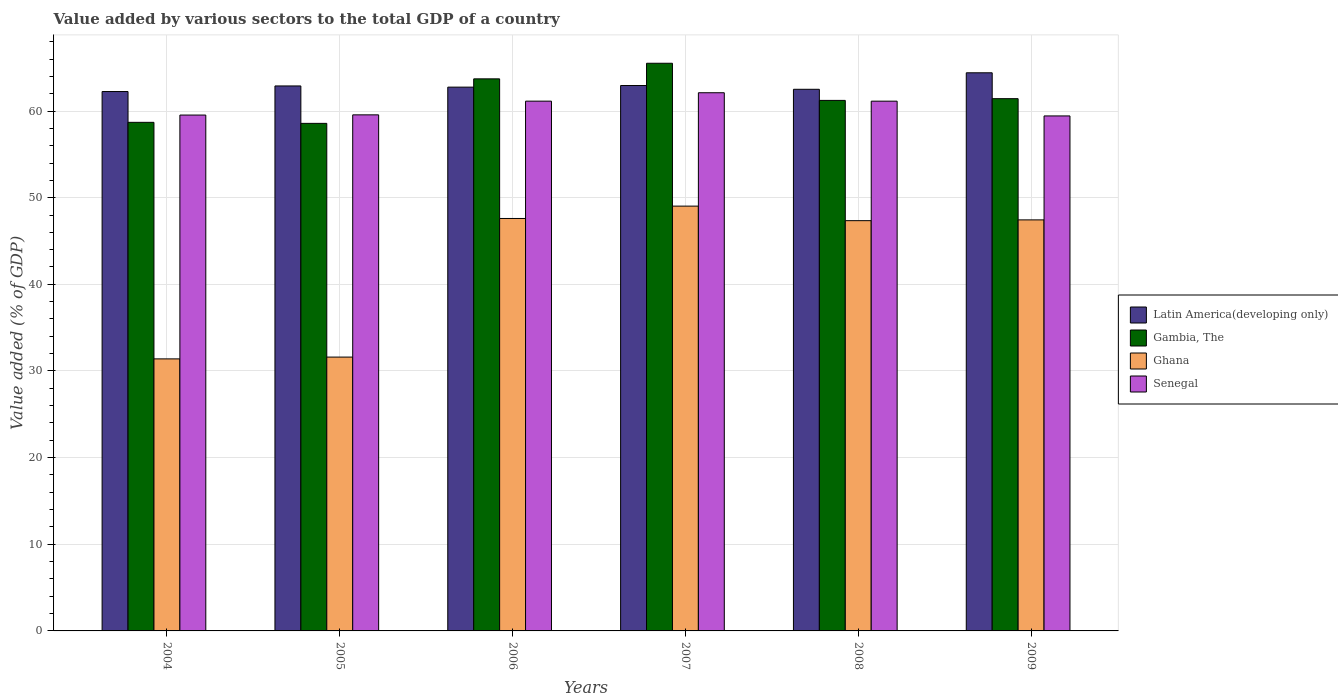How many different coloured bars are there?
Ensure brevity in your answer.  4. Are the number of bars per tick equal to the number of legend labels?
Provide a succinct answer. Yes. How many bars are there on the 6th tick from the right?
Your answer should be compact. 4. What is the label of the 3rd group of bars from the left?
Offer a very short reply. 2006. In how many cases, is the number of bars for a given year not equal to the number of legend labels?
Your answer should be compact. 0. What is the value added by various sectors to the total GDP in Latin America(developing only) in 2009?
Ensure brevity in your answer.  64.41. Across all years, what is the maximum value added by various sectors to the total GDP in Ghana?
Ensure brevity in your answer.  49.03. Across all years, what is the minimum value added by various sectors to the total GDP in Gambia, The?
Your answer should be compact. 58.58. What is the total value added by various sectors to the total GDP in Gambia, The in the graph?
Your answer should be very brief. 369.15. What is the difference between the value added by various sectors to the total GDP in Ghana in 2008 and that in 2009?
Ensure brevity in your answer.  -0.09. What is the difference between the value added by various sectors to the total GDP in Gambia, The in 2009 and the value added by various sectors to the total GDP in Ghana in 2006?
Your response must be concise. 13.83. What is the average value added by various sectors to the total GDP in Gambia, The per year?
Ensure brevity in your answer.  61.53. In the year 2007, what is the difference between the value added by various sectors to the total GDP in Gambia, The and value added by various sectors to the total GDP in Senegal?
Offer a terse response. 3.4. What is the ratio of the value added by various sectors to the total GDP in Senegal in 2005 to that in 2007?
Keep it short and to the point. 0.96. What is the difference between the highest and the second highest value added by various sectors to the total GDP in Gambia, The?
Offer a very short reply. 1.8. What is the difference between the highest and the lowest value added by various sectors to the total GDP in Gambia, The?
Provide a succinct answer. 6.94. In how many years, is the value added by various sectors to the total GDP in Gambia, The greater than the average value added by various sectors to the total GDP in Gambia, The taken over all years?
Your answer should be very brief. 2. Is it the case that in every year, the sum of the value added by various sectors to the total GDP in Latin America(developing only) and value added by various sectors to the total GDP in Ghana is greater than the sum of value added by various sectors to the total GDP in Gambia, The and value added by various sectors to the total GDP in Senegal?
Ensure brevity in your answer.  No. What does the 2nd bar from the left in 2005 represents?
Offer a very short reply. Gambia, The. What does the 1st bar from the right in 2008 represents?
Provide a succinct answer. Senegal. How many years are there in the graph?
Ensure brevity in your answer.  6. Are the values on the major ticks of Y-axis written in scientific E-notation?
Give a very brief answer. No. How are the legend labels stacked?
Offer a terse response. Vertical. What is the title of the graph?
Offer a terse response. Value added by various sectors to the total GDP of a country. Does "Tonga" appear as one of the legend labels in the graph?
Offer a very short reply. No. What is the label or title of the Y-axis?
Provide a succinct answer. Value added (% of GDP). What is the Value added (% of GDP) of Latin America(developing only) in 2004?
Make the answer very short. 62.25. What is the Value added (% of GDP) of Gambia, The in 2004?
Your response must be concise. 58.7. What is the Value added (% of GDP) in Ghana in 2004?
Make the answer very short. 31.39. What is the Value added (% of GDP) in Senegal in 2004?
Your answer should be very brief. 59.54. What is the Value added (% of GDP) of Latin America(developing only) in 2005?
Provide a short and direct response. 62.89. What is the Value added (% of GDP) of Gambia, The in 2005?
Provide a short and direct response. 58.58. What is the Value added (% of GDP) of Ghana in 2005?
Offer a very short reply. 31.6. What is the Value added (% of GDP) in Senegal in 2005?
Keep it short and to the point. 59.56. What is the Value added (% of GDP) in Latin America(developing only) in 2006?
Your response must be concise. 62.76. What is the Value added (% of GDP) of Gambia, The in 2006?
Make the answer very short. 63.71. What is the Value added (% of GDP) of Ghana in 2006?
Your answer should be compact. 47.6. What is the Value added (% of GDP) in Senegal in 2006?
Give a very brief answer. 61.14. What is the Value added (% of GDP) of Latin America(developing only) in 2007?
Provide a short and direct response. 62.94. What is the Value added (% of GDP) of Gambia, The in 2007?
Offer a very short reply. 65.51. What is the Value added (% of GDP) in Ghana in 2007?
Your response must be concise. 49.03. What is the Value added (% of GDP) of Senegal in 2007?
Provide a succinct answer. 62.11. What is the Value added (% of GDP) in Latin America(developing only) in 2008?
Ensure brevity in your answer.  62.51. What is the Value added (% of GDP) of Gambia, The in 2008?
Offer a very short reply. 61.23. What is the Value added (% of GDP) in Ghana in 2008?
Make the answer very short. 47.35. What is the Value added (% of GDP) in Senegal in 2008?
Your response must be concise. 61.14. What is the Value added (% of GDP) in Latin America(developing only) in 2009?
Keep it short and to the point. 64.41. What is the Value added (% of GDP) of Gambia, The in 2009?
Keep it short and to the point. 61.43. What is the Value added (% of GDP) in Ghana in 2009?
Keep it short and to the point. 47.44. What is the Value added (% of GDP) of Senegal in 2009?
Offer a terse response. 59.43. Across all years, what is the maximum Value added (% of GDP) in Latin America(developing only)?
Provide a succinct answer. 64.41. Across all years, what is the maximum Value added (% of GDP) of Gambia, The?
Your response must be concise. 65.51. Across all years, what is the maximum Value added (% of GDP) in Ghana?
Your answer should be very brief. 49.03. Across all years, what is the maximum Value added (% of GDP) in Senegal?
Make the answer very short. 62.11. Across all years, what is the minimum Value added (% of GDP) of Latin America(developing only)?
Ensure brevity in your answer.  62.25. Across all years, what is the minimum Value added (% of GDP) of Gambia, The?
Make the answer very short. 58.58. Across all years, what is the minimum Value added (% of GDP) in Ghana?
Provide a short and direct response. 31.39. Across all years, what is the minimum Value added (% of GDP) in Senegal?
Make the answer very short. 59.43. What is the total Value added (% of GDP) in Latin America(developing only) in the graph?
Keep it short and to the point. 377.77. What is the total Value added (% of GDP) of Gambia, The in the graph?
Give a very brief answer. 369.15. What is the total Value added (% of GDP) of Ghana in the graph?
Keep it short and to the point. 254.41. What is the total Value added (% of GDP) in Senegal in the graph?
Offer a very short reply. 362.92. What is the difference between the Value added (% of GDP) of Latin America(developing only) in 2004 and that in 2005?
Your answer should be compact. -0.65. What is the difference between the Value added (% of GDP) of Gambia, The in 2004 and that in 2005?
Your response must be concise. 0.12. What is the difference between the Value added (% of GDP) of Ghana in 2004 and that in 2005?
Your answer should be compact. -0.21. What is the difference between the Value added (% of GDP) in Senegal in 2004 and that in 2005?
Your response must be concise. -0.02. What is the difference between the Value added (% of GDP) in Latin America(developing only) in 2004 and that in 2006?
Provide a succinct answer. -0.51. What is the difference between the Value added (% of GDP) in Gambia, The in 2004 and that in 2006?
Provide a short and direct response. -5.02. What is the difference between the Value added (% of GDP) in Ghana in 2004 and that in 2006?
Give a very brief answer. -16.2. What is the difference between the Value added (% of GDP) of Senegal in 2004 and that in 2006?
Make the answer very short. -1.61. What is the difference between the Value added (% of GDP) of Latin America(developing only) in 2004 and that in 2007?
Give a very brief answer. -0.69. What is the difference between the Value added (% of GDP) of Gambia, The in 2004 and that in 2007?
Keep it short and to the point. -6.82. What is the difference between the Value added (% of GDP) in Ghana in 2004 and that in 2007?
Offer a terse response. -17.63. What is the difference between the Value added (% of GDP) in Senegal in 2004 and that in 2007?
Your answer should be compact. -2.57. What is the difference between the Value added (% of GDP) in Latin America(developing only) in 2004 and that in 2008?
Make the answer very short. -0.26. What is the difference between the Value added (% of GDP) of Gambia, The in 2004 and that in 2008?
Make the answer very short. -2.53. What is the difference between the Value added (% of GDP) of Ghana in 2004 and that in 2008?
Provide a short and direct response. -15.95. What is the difference between the Value added (% of GDP) in Senegal in 2004 and that in 2008?
Make the answer very short. -1.6. What is the difference between the Value added (% of GDP) of Latin America(developing only) in 2004 and that in 2009?
Your response must be concise. -2.16. What is the difference between the Value added (% of GDP) in Gambia, The in 2004 and that in 2009?
Keep it short and to the point. -2.73. What is the difference between the Value added (% of GDP) of Ghana in 2004 and that in 2009?
Provide a short and direct response. -16.04. What is the difference between the Value added (% of GDP) in Senegal in 2004 and that in 2009?
Offer a very short reply. 0.1. What is the difference between the Value added (% of GDP) of Latin America(developing only) in 2005 and that in 2006?
Provide a short and direct response. 0.14. What is the difference between the Value added (% of GDP) in Gambia, The in 2005 and that in 2006?
Ensure brevity in your answer.  -5.14. What is the difference between the Value added (% of GDP) in Ghana in 2005 and that in 2006?
Provide a short and direct response. -16. What is the difference between the Value added (% of GDP) of Senegal in 2005 and that in 2006?
Provide a succinct answer. -1.58. What is the difference between the Value added (% of GDP) of Latin America(developing only) in 2005 and that in 2007?
Make the answer very short. -0.05. What is the difference between the Value added (% of GDP) in Gambia, The in 2005 and that in 2007?
Your answer should be compact. -6.94. What is the difference between the Value added (% of GDP) in Ghana in 2005 and that in 2007?
Ensure brevity in your answer.  -17.42. What is the difference between the Value added (% of GDP) of Senegal in 2005 and that in 2007?
Offer a very short reply. -2.55. What is the difference between the Value added (% of GDP) of Latin America(developing only) in 2005 and that in 2008?
Provide a short and direct response. 0.38. What is the difference between the Value added (% of GDP) in Gambia, The in 2005 and that in 2008?
Offer a very short reply. -2.65. What is the difference between the Value added (% of GDP) of Ghana in 2005 and that in 2008?
Make the answer very short. -15.74. What is the difference between the Value added (% of GDP) in Senegal in 2005 and that in 2008?
Your answer should be very brief. -1.58. What is the difference between the Value added (% of GDP) in Latin America(developing only) in 2005 and that in 2009?
Make the answer very short. -1.52. What is the difference between the Value added (% of GDP) of Gambia, The in 2005 and that in 2009?
Provide a short and direct response. -2.85. What is the difference between the Value added (% of GDP) of Ghana in 2005 and that in 2009?
Your answer should be compact. -15.83. What is the difference between the Value added (% of GDP) in Senegal in 2005 and that in 2009?
Ensure brevity in your answer.  0.12. What is the difference between the Value added (% of GDP) of Latin America(developing only) in 2006 and that in 2007?
Ensure brevity in your answer.  -0.19. What is the difference between the Value added (% of GDP) in Gambia, The in 2006 and that in 2007?
Provide a succinct answer. -1.8. What is the difference between the Value added (% of GDP) in Ghana in 2006 and that in 2007?
Keep it short and to the point. -1.43. What is the difference between the Value added (% of GDP) of Senegal in 2006 and that in 2007?
Your answer should be very brief. -0.97. What is the difference between the Value added (% of GDP) of Latin America(developing only) in 2006 and that in 2008?
Make the answer very short. 0.25. What is the difference between the Value added (% of GDP) of Gambia, The in 2006 and that in 2008?
Ensure brevity in your answer.  2.49. What is the difference between the Value added (% of GDP) of Ghana in 2006 and that in 2008?
Your answer should be compact. 0.25. What is the difference between the Value added (% of GDP) in Senegal in 2006 and that in 2008?
Your response must be concise. 0. What is the difference between the Value added (% of GDP) in Latin America(developing only) in 2006 and that in 2009?
Give a very brief answer. -1.66. What is the difference between the Value added (% of GDP) in Gambia, The in 2006 and that in 2009?
Ensure brevity in your answer.  2.29. What is the difference between the Value added (% of GDP) of Ghana in 2006 and that in 2009?
Offer a terse response. 0.16. What is the difference between the Value added (% of GDP) of Senegal in 2006 and that in 2009?
Offer a terse response. 1.71. What is the difference between the Value added (% of GDP) of Latin America(developing only) in 2007 and that in 2008?
Offer a very short reply. 0.43. What is the difference between the Value added (% of GDP) of Gambia, The in 2007 and that in 2008?
Offer a terse response. 4.29. What is the difference between the Value added (% of GDP) in Ghana in 2007 and that in 2008?
Provide a succinct answer. 1.68. What is the difference between the Value added (% of GDP) of Senegal in 2007 and that in 2008?
Your response must be concise. 0.97. What is the difference between the Value added (% of GDP) in Latin America(developing only) in 2007 and that in 2009?
Your answer should be compact. -1.47. What is the difference between the Value added (% of GDP) of Gambia, The in 2007 and that in 2009?
Provide a short and direct response. 4.09. What is the difference between the Value added (% of GDP) in Ghana in 2007 and that in 2009?
Provide a short and direct response. 1.59. What is the difference between the Value added (% of GDP) in Senegal in 2007 and that in 2009?
Ensure brevity in your answer.  2.68. What is the difference between the Value added (% of GDP) in Latin America(developing only) in 2008 and that in 2009?
Provide a short and direct response. -1.9. What is the difference between the Value added (% of GDP) in Gambia, The in 2008 and that in 2009?
Your answer should be very brief. -0.2. What is the difference between the Value added (% of GDP) of Ghana in 2008 and that in 2009?
Your answer should be compact. -0.09. What is the difference between the Value added (% of GDP) of Senegal in 2008 and that in 2009?
Your answer should be very brief. 1.71. What is the difference between the Value added (% of GDP) in Latin America(developing only) in 2004 and the Value added (% of GDP) in Gambia, The in 2005?
Provide a short and direct response. 3.67. What is the difference between the Value added (% of GDP) in Latin America(developing only) in 2004 and the Value added (% of GDP) in Ghana in 2005?
Give a very brief answer. 30.65. What is the difference between the Value added (% of GDP) in Latin America(developing only) in 2004 and the Value added (% of GDP) in Senegal in 2005?
Your answer should be very brief. 2.69. What is the difference between the Value added (% of GDP) in Gambia, The in 2004 and the Value added (% of GDP) in Ghana in 2005?
Give a very brief answer. 27.09. What is the difference between the Value added (% of GDP) in Gambia, The in 2004 and the Value added (% of GDP) in Senegal in 2005?
Offer a very short reply. -0.86. What is the difference between the Value added (% of GDP) of Ghana in 2004 and the Value added (% of GDP) of Senegal in 2005?
Your answer should be very brief. -28.16. What is the difference between the Value added (% of GDP) in Latin America(developing only) in 2004 and the Value added (% of GDP) in Gambia, The in 2006?
Offer a terse response. -1.47. What is the difference between the Value added (% of GDP) in Latin America(developing only) in 2004 and the Value added (% of GDP) in Ghana in 2006?
Your response must be concise. 14.65. What is the difference between the Value added (% of GDP) in Latin America(developing only) in 2004 and the Value added (% of GDP) in Senegal in 2006?
Offer a very short reply. 1.11. What is the difference between the Value added (% of GDP) in Gambia, The in 2004 and the Value added (% of GDP) in Ghana in 2006?
Keep it short and to the point. 11.1. What is the difference between the Value added (% of GDP) in Gambia, The in 2004 and the Value added (% of GDP) in Senegal in 2006?
Give a very brief answer. -2.44. What is the difference between the Value added (% of GDP) of Ghana in 2004 and the Value added (% of GDP) of Senegal in 2006?
Provide a short and direct response. -29.75. What is the difference between the Value added (% of GDP) of Latin America(developing only) in 2004 and the Value added (% of GDP) of Gambia, The in 2007?
Your answer should be compact. -3.26. What is the difference between the Value added (% of GDP) of Latin America(developing only) in 2004 and the Value added (% of GDP) of Ghana in 2007?
Give a very brief answer. 13.22. What is the difference between the Value added (% of GDP) in Latin America(developing only) in 2004 and the Value added (% of GDP) in Senegal in 2007?
Give a very brief answer. 0.14. What is the difference between the Value added (% of GDP) in Gambia, The in 2004 and the Value added (% of GDP) in Ghana in 2007?
Ensure brevity in your answer.  9.67. What is the difference between the Value added (% of GDP) in Gambia, The in 2004 and the Value added (% of GDP) in Senegal in 2007?
Your response must be concise. -3.41. What is the difference between the Value added (% of GDP) of Ghana in 2004 and the Value added (% of GDP) of Senegal in 2007?
Provide a short and direct response. -30.72. What is the difference between the Value added (% of GDP) in Latin America(developing only) in 2004 and the Value added (% of GDP) in Gambia, The in 2008?
Keep it short and to the point. 1.02. What is the difference between the Value added (% of GDP) of Latin America(developing only) in 2004 and the Value added (% of GDP) of Ghana in 2008?
Provide a short and direct response. 14.9. What is the difference between the Value added (% of GDP) of Latin America(developing only) in 2004 and the Value added (% of GDP) of Senegal in 2008?
Ensure brevity in your answer.  1.11. What is the difference between the Value added (% of GDP) of Gambia, The in 2004 and the Value added (% of GDP) of Ghana in 2008?
Give a very brief answer. 11.35. What is the difference between the Value added (% of GDP) in Gambia, The in 2004 and the Value added (% of GDP) in Senegal in 2008?
Keep it short and to the point. -2.44. What is the difference between the Value added (% of GDP) in Ghana in 2004 and the Value added (% of GDP) in Senegal in 2008?
Ensure brevity in your answer.  -29.74. What is the difference between the Value added (% of GDP) in Latin America(developing only) in 2004 and the Value added (% of GDP) in Gambia, The in 2009?
Ensure brevity in your answer.  0.82. What is the difference between the Value added (% of GDP) in Latin America(developing only) in 2004 and the Value added (% of GDP) in Ghana in 2009?
Keep it short and to the point. 14.81. What is the difference between the Value added (% of GDP) of Latin America(developing only) in 2004 and the Value added (% of GDP) of Senegal in 2009?
Make the answer very short. 2.82. What is the difference between the Value added (% of GDP) of Gambia, The in 2004 and the Value added (% of GDP) of Ghana in 2009?
Provide a succinct answer. 11.26. What is the difference between the Value added (% of GDP) of Gambia, The in 2004 and the Value added (% of GDP) of Senegal in 2009?
Your response must be concise. -0.74. What is the difference between the Value added (% of GDP) in Ghana in 2004 and the Value added (% of GDP) in Senegal in 2009?
Ensure brevity in your answer.  -28.04. What is the difference between the Value added (% of GDP) of Latin America(developing only) in 2005 and the Value added (% of GDP) of Gambia, The in 2006?
Offer a very short reply. -0.82. What is the difference between the Value added (% of GDP) of Latin America(developing only) in 2005 and the Value added (% of GDP) of Ghana in 2006?
Keep it short and to the point. 15.29. What is the difference between the Value added (% of GDP) in Latin America(developing only) in 2005 and the Value added (% of GDP) in Senegal in 2006?
Ensure brevity in your answer.  1.75. What is the difference between the Value added (% of GDP) in Gambia, The in 2005 and the Value added (% of GDP) in Ghana in 2006?
Offer a very short reply. 10.98. What is the difference between the Value added (% of GDP) of Gambia, The in 2005 and the Value added (% of GDP) of Senegal in 2006?
Provide a short and direct response. -2.56. What is the difference between the Value added (% of GDP) in Ghana in 2005 and the Value added (% of GDP) in Senegal in 2006?
Offer a terse response. -29.54. What is the difference between the Value added (% of GDP) in Latin America(developing only) in 2005 and the Value added (% of GDP) in Gambia, The in 2007?
Keep it short and to the point. -2.62. What is the difference between the Value added (% of GDP) of Latin America(developing only) in 2005 and the Value added (% of GDP) of Ghana in 2007?
Provide a succinct answer. 13.87. What is the difference between the Value added (% of GDP) in Latin America(developing only) in 2005 and the Value added (% of GDP) in Senegal in 2007?
Your answer should be compact. 0.78. What is the difference between the Value added (% of GDP) of Gambia, The in 2005 and the Value added (% of GDP) of Ghana in 2007?
Your response must be concise. 9.55. What is the difference between the Value added (% of GDP) in Gambia, The in 2005 and the Value added (% of GDP) in Senegal in 2007?
Your response must be concise. -3.53. What is the difference between the Value added (% of GDP) of Ghana in 2005 and the Value added (% of GDP) of Senegal in 2007?
Offer a very short reply. -30.51. What is the difference between the Value added (% of GDP) in Latin America(developing only) in 2005 and the Value added (% of GDP) in Gambia, The in 2008?
Your answer should be compact. 1.67. What is the difference between the Value added (% of GDP) of Latin America(developing only) in 2005 and the Value added (% of GDP) of Ghana in 2008?
Your response must be concise. 15.55. What is the difference between the Value added (% of GDP) of Latin America(developing only) in 2005 and the Value added (% of GDP) of Senegal in 2008?
Offer a terse response. 1.76. What is the difference between the Value added (% of GDP) in Gambia, The in 2005 and the Value added (% of GDP) in Ghana in 2008?
Offer a terse response. 11.23. What is the difference between the Value added (% of GDP) in Gambia, The in 2005 and the Value added (% of GDP) in Senegal in 2008?
Your response must be concise. -2.56. What is the difference between the Value added (% of GDP) of Ghana in 2005 and the Value added (% of GDP) of Senegal in 2008?
Give a very brief answer. -29.54. What is the difference between the Value added (% of GDP) in Latin America(developing only) in 2005 and the Value added (% of GDP) in Gambia, The in 2009?
Your answer should be compact. 1.47. What is the difference between the Value added (% of GDP) in Latin America(developing only) in 2005 and the Value added (% of GDP) in Ghana in 2009?
Offer a very short reply. 15.46. What is the difference between the Value added (% of GDP) of Latin America(developing only) in 2005 and the Value added (% of GDP) of Senegal in 2009?
Offer a very short reply. 3.46. What is the difference between the Value added (% of GDP) in Gambia, The in 2005 and the Value added (% of GDP) in Ghana in 2009?
Give a very brief answer. 11.14. What is the difference between the Value added (% of GDP) in Gambia, The in 2005 and the Value added (% of GDP) in Senegal in 2009?
Make the answer very short. -0.86. What is the difference between the Value added (% of GDP) in Ghana in 2005 and the Value added (% of GDP) in Senegal in 2009?
Your response must be concise. -27.83. What is the difference between the Value added (% of GDP) in Latin America(developing only) in 2006 and the Value added (% of GDP) in Gambia, The in 2007?
Offer a terse response. -2.76. What is the difference between the Value added (% of GDP) of Latin America(developing only) in 2006 and the Value added (% of GDP) of Ghana in 2007?
Your answer should be very brief. 13.73. What is the difference between the Value added (% of GDP) in Latin America(developing only) in 2006 and the Value added (% of GDP) in Senegal in 2007?
Your answer should be compact. 0.65. What is the difference between the Value added (% of GDP) of Gambia, The in 2006 and the Value added (% of GDP) of Ghana in 2007?
Keep it short and to the point. 14.69. What is the difference between the Value added (% of GDP) of Gambia, The in 2006 and the Value added (% of GDP) of Senegal in 2007?
Give a very brief answer. 1.6. What is the difference between the Value added (% of GDP) in Ghana in 2006 and the Value added (% of GDP) in Senegal in 2007?
Your answer should be compact. -14.51. What is the difference between the Value added (% of GDP) of Latin America(developing only) in 2006 and the Value added (% of GDP) of Gambia, The in 2008?
Make the answer very short. 1.53. What is the difference between the Value added (% of GDP) in Latin America(developing only) in 2006 and the Value added (% of GDP) in Ghana in 2008?
Keep it short and to the point. 15.41. What is the difference between the Value added (% of GDP) of Latin America(developing only) in 2006 and the Value added (% of GDP) of Senegal in 2008?
Make the answer very short. 1.62. What is the difference between the Value added (% of GDP) in Gambia, The in 2006 and the Value added (% of GDP) in Ghana in 2008?
Your answer should be compact. 16.37. What is the difference between the Value added (% of GDP) of Gambia, The in 2006 and the Value added (% of GDP) of Senegal in 2008?
Give a very brief answer. 2.57. What is the difference between the Value added (% of GDP) in Ghana in 2006 and the Value added (% of GDP) in Senegal in 2008?
Provide a succinct answer. -13.54. What is the difference between the Value added (% of GDP) in Latin America(developing only) in 2006 and the Value added (% of GDP) in Gambia, The in 2009?
Keep it short and to the point. 1.33. What is the difference between the Value added (% of GDP) in Latin America(developing only) in 2006 and the Value added (% of GDP) in Ghana in 2009?
Offer a very short reply. 15.32. What is the difference between the Value added (% of GDP) in Latin America(developing only) in 2006 and the Value added (% of GDP) in Senegal in 2009?
Your response must be concise. 3.32. What is the difference between the Value added (% of GDP) of Gambia, The in 2006 and the Value added (% of GDP) of Ghana in 2009?
Give a very brief answer. 16.28. What is the difference between the Value added (% of GDP) of Gambia, The in 2006 and the Value added (% of GDP) of Senegal in 2009?
Your answer should be very brief. 4.28. What is the difference between the Value added (% of GDP) of Ghana in 2006 and the Value added (% of GDP) of Senegal in 2009?
Make the answer very short. -11.83. What is the difference between the Value added (% of GDP) of Latin America(developing only) in 2007 and the Value added (% of GDP) of Gambia, The in 2008?
Your answer should be very brief. 1.72. What is the difference between the Value added (% of GDP) of Latin America(developing only) in 2007 and the Value added (% of GDP) of Ghana in 2008?
Offer a terse response. 15.6. What is the difference between the Value added (% of GDP) of Latin America(developing only) in 2007 and the Value added (% of GDP) of Senegal in 2008?
Provide a short and direct response. 1.8. What is the difference between the Value added (% of GDP) in Gambia, The in 2007 and the Value added (% of GDP) in Ghana in 2008?
Provide a succinct answer. 18.17. What is the difference between the Value added (% of GDP) in Gambia, The in 2007 and the Value added (% of GDP) in Senegal in 2008?
Provide a short and direct response. 4.37. What is the difference between the Value added (% of GDP) in Ghana in 2007 and the Value added (% of GDP) in Senegal in 2008?
Make the answer very short. -12.11. What is the difference between the Value added (% of GDP) of Latin America(developing only) in 2007 and the Value added (% of GDP) of Gambia, The in 2009?
Ensure brevity in your answer.  1.52. What is the difference between the Value added (% of GDP) in Latin America(developing only) in 2007 and the Value added (% of GDP) in Ghana in 2009?
Your answer should be compact. 15.51. What is the difference between the Value added (% of GDP) of Latin America(developing only) in 2007 and the Value added (% of GDP) of Senegal in 2009?
Your answer should be compact. 3.51. What is the difference between the Value added (% of GDP) of Gambia, The in 2007 and the Value added (% of GDP) of Ghana in 2009?
Give a very brief answer. 18.08. What is the difference between the Value added (% of GDP) of Gambia, The in 2007 and the Value added (% of GDP) of Senegal in 2009?
Provide a succinct answer. 6.08. What is the difference between the Value added (% of GDP) of Ghana in 2007 and the Value added (% of GDP) of Senegal in 2009?
Provide a succinct answer. -10.41. What is the difference between the Value added (% of GDP) in Latin America(developing only) in 2008 and the Value added (% of GDP) in Gambia, The in 2009?
Your response must be concise. 1.08. What is the difference between the Value added (% of GDP) in Latin America(developing only) in 2008 and the Value added (% of GDP) in Ghana in 2009?
Provide a succinct answer. 15.07. What is the difference between the Value added (% of GDP) of Latin America(developing only) in 2008 and the Value added (% of GDP) of Senegal in 2009?
Provide a succinct answer. 3.08. What is the difference between the Value added (% of GDP) of Gambia, The in 2008 and the Value added (% of GDP) of Ghana in 2009?
Provide a short and direct response. 13.79. What is the difference between the Value added (% of GDP) in Gambia, The in 2008 and the Value added (% of GDP) in Senegal in 2009?
Offer a very short reply. 1.79. What is the difference between the Value added (% of GDP) in Ghana in 2008 and the Value added (% of GDP) in Senegal in 2009?
Your response must be concise. -12.09. What is the average Value added (% of GDP) in Latin America(developing only) per year?
Provide a succinct answer. 62.96. What is the average Value added (% of GDP) of Gambia, The per year?
Your answer should be very brief. 61.53. What is the average Value added (% of GDP) of Ghana per year?
Offer a terse response. 42.4. What is the average Value added (% of GDP) of Senegal per year?
Offer a terse response. 60.49. In the year 2004, what is the difference between the Value added (% of GDP) of Latin America(developing only) and Value added (% of GDP) of Gambia, The?
Your answer should be compact. 3.55. In the year 2004, what is the difference between the Value added (% of GDP) of Latin America(developing only) and Value added (% of GDP) of Ghana?
Provide a short and direct response. 30.85. In the year 2004, what is the difference between the Value added (% of GDP) in Latin America(developing only) and Value added (% of GDP) in Senegal?
Your answer should be very brief. 2.71. In the year 2004, what is the difference between the Value added (% of GDP) of Gambia, The and Value added (% of GDP) of Ghana?
Provide a short and direct response. 27.3. In the year 2004, what is the difference between the Value added (% of GDP) in Gambia, The and Value added (% of GDP) in Senegal?
Ensure brevity in your answer.  -0.84. In the year 2004, what is the difference between the Value added (% of GDP) in Ghana and Value added (% of GDP) in Senegal?
Give a very brief answer. -28.14. In the year 2005, what is the difference between the Value added (% of GDP) in Latin America(developing only) and Value added (% of GDP) in Gambia, The?
Your answer should be very brief. 4.32. In the year 2005, what is the difference between the Value added (% of GDP) of Latin America(developing only) and Value added (% of GDP) of Ghana?
Make the answer very short. 31.29. In the year 2005, what is the difference between the Value added (% of GDP) in Latin America(developing only) and Value added (% of GDP) in Senegal?
Your answer should be very brief. 3.34. In the year 2005, what is the difference between the Value added (% of GDP) of Gambia, The and Value added (% of GDP) of Ghana?
Keep it short and to the point. 26.97. In the year 2005, what is the difference between the Value added (% of GDP) of Gambia, The and Value added (% of GDP) of Senegal?
Offer a terse response. -0.98. In the year 2005, what is the difference between the Value added (% of GDP) of Ghana and Value added (% of GDP) of Senegal?
Your answer should be very brief. -27.96. In the year 2006, what is the difference between the Value added (% of GDP) in Latin America(developing only) and Value added (% of GDP) in Gambia, The?
Give a very brief answer. -0.96. In the year 2006, what is the difference between the Value added (% of GDP) in Latin America(developing only) and Value added (% of GDP) in Ghana?
Your response must be concise. 15.16. In the year 2006, what is the difference between the Value added (% of GDP) of Latin America(developing only) and Value added (% of GDP) of Senegal?
Your answer should be very brief. 1.62. In the year 2006, what is the difference between the Value added (% of GDP) of Gambia, The and Value added (% of GDP) of Ghana?
Provide a succinct answer. 16.11. In the year 2006, what is the difference between the Value added (% of GDP) of Gambia, The and Value added (% of GDP) of Senegal?
Your response must be concise. 2.57. In the year 2006, what is the difference between the Value added (% of GDP) in Ghana and Value added (% of GDP) in Senegal?
Offer a very short reply. -13.54. In the year 2007, what is the difference between the Value added (% of GDP) in Latin America(developing only) and Value added (% of GDP) in Gambia, The?
Keep it short and to the point. -2.57. In the year 2007, what is the difference between the Value added (% of GDP) of Latin America(developing only) and Value added (% of GDP) of Ghana?
Provide a succinct answer. 13.92. In the year 2007, what is the difference between the Value added (% of GDP) in Latin America(developing only) and Value added (% of GDP) in Senegal?
Provide a short and direct response. 0.83. In the year 2007, what is the difference between the Value added (% of GDP) in Gambia, The and Value added (% of GDP) in Ghana?
Keep it short and to the point. 16.49. In the year 2007, what is the difference between the Value added (% of GDP) of Gambia, The and Value added (% of GDP) of Senegal?
Ensure brevity in your answer.  3.4. In the year 2007, what is the difference between the Value added (% of GDP) of Ghana and Value added (% of GDP) of Senegal?
Offer a very short reply. -13.08. In the year 2008, what is the difference between the Value added (% of GDP) of Latin America(developing only) and Value added (% of GDP) of Gambia, The?
Provide a short and direct response. 1.28. In the year 2008, what is the difference between the Value added (% of GDP) in Latin America(developing only) and Value added (% of GDP) in Ghana?
Ensure brevity in your answer.  15.16. In the year 2008, what is the difference between the Value added (% of GDP) in Latin America(developing only) and Value added (% of GDP) in Senegal?
Provide a succinct answer. 1.37. In the year 2008, what is the difference between the Value added (% of GDP) of Gambia, The and Value added (% of GDP) of Ghana?
Provide a short and direct response. 13.88. In the year 2008, what is the difference between the Value added (% of GDP) of Gambia, The and Value added (% of GDP) of Senegal?
Give a very brief answer. 0.09. In the year 2008, what is the difference between the Value added (% of GDP) in Ghana and Value added (% of GDP) in Senegal?
Offer a terse response. -13.79. In the year 2009, what is the difference between the Value added (% of GDP) in Latin America(developing only) and Value added (% of GDP) in Gambia, The?
Offer a terse response. 2.99. In the year 2009, what is the difference between the Value added (% of GDP) of Latin America(developing only) and Value added (% of GDP) of Ghana?
Keep it short and to the point. 16.98. In the year 2009, what is the difference between the Value added (% of GDP) of Latin America(developing only) and Value added (% of GDP) of Senegal?
Offer a terse response. 4.98. In the year 2009, what is the difference between the Value added (% of GDP) in Gambia, The and Value added (% of GDP) in Ghana?
Offer a very short reply. 13.99. In the year 2009, what is the difference between the Value added (% of GDP) of Gambia, The and Value added (% of GDP) of Senegal?
Your answer should be very brief. 1.99. In the year 2009, what is the difference between the Value added (% of GDP) of Ghana and Value added (% of GDP) of Senegal?
Your response must be concise. -12. What is the ratio of the Value added (% of GDP) in Latin America(developing only) in 2004 to that in 2005?
Your answer should be compact. 0.99. What is the ratio of the Value added (% of GDP) of Senegal in 2004 to that in 2005?
Offer a terse response. 1. What is the ratio of the Value added (% of GDP) of Latin America(developing only) in 2004 to that in 2006?
Give a very brief answer. 0.99. What is the ratio of the Value added (% of GDP) in Gambia, The in 2004 to that in 2006?
Keep it short and to the point. 0.92. What is the ratio of the Value added (% of GDP) in Ghana in 2004 to that in 2006?
Your answer should be compact. 0.66. What is the ratio of the Value added (% of GDP) of Senegal in 2004 to that in 2006?
Your answer should be very brief. 0.97. What is the ratio of the Value added (% of GDP) of Gambia, The in 2004 to that in 2007?
Your answer should be very brief. 0.9. What is the ratio of the Value added (% of GDP) in Ghana in 2004 to that in 2007?
Your response must be concise. 0.64. What is the ratio of the Value added (% of GDP) of Senegal in 2004 to that in 2007?
Your answer should be very brief. 0.96. What is the ratio of the Value added (% of GDP) of Gambia, The in 2004 to that in 2008?
Offer a very short reply. 0.96. What is the ratio of the Value added (% of GDP) of Ghana in 2004 to that in 2008?
Keep it short and to the point. 0.66. What is the ratio of the Value added (% of GDP) in Senegal in 2004 to that in 2008?
Your answer should be very brief. 0.97. What is the ratio of the Value added (% of GDP) in Latin America(developing only) in 2004 to that in 2009?
Make the answer very short. 0.97. What is the ratio of the Value added (% of GDP) of Gambia, The in 2004 to that in 2009?
Your response must be concise. 0.96. What is the ratio of the Value added (% of GDP) in Ghana in 2004 to that in 2009?
Provide a short and direct response. 0.66. What is the ratio of the Value added (% of GDP) of Latin America(developing only) in 2005 to that in 2006?
Your response must be concise. 1. What is the ratio of the Value added (% of GDP) in Gambia, The in 2005 to that in 2006?
Your response must be concise. 0.92. What is the ratio of the Value added (% of GDP) in Ghana in 2005 to that in 2006?
Provide a short and direct response. 0.66. What is the ratio of the Value added (% of GDP) in Senegal in 2005 to that in 2006?
Ensure brevity in your answer.  0.97. What is the ratio of the Value added (% of GDP) in Gambia, The in 2005 to that in 2007?
Provide a short and direct response. 0.89. What is the ratio of the Value added (% of GDP) in Ghana in 2005 to that in 2007?
Make the answer very short. 0.64. What is the ratio of the Value added (% of GDP) of Senegal in 2005 to that in 2007?
Offer a very short reply. 0.96. What is the ratio of the Value added (% of GDP) in Gambia, The in 2005 to that in 2008?
Your answer should be compact. 0.96. What is the ratio of the Value added (% of GDP) of Ghana in 2005 to that in 2008?
Your answer should be very brief. 0.67. What is the ratio of the Value added (% of GDP) of Senegal in 2005 to that in 2008?
Offer a terse response. 0.97. What is the ratio of the Value added (% of GDP) in Latin America(developing only) in 2005 to that in 2009?
Make the answer very short. 0.98. What is the ratio of the Value added (% of GDP) in Gambia, The in 2005 to that in 2009?
Offer a terse response. 0.95. What is the ratio of the Value added (% of GDP) in Ghana in 2005 to that in 2009?
Make the answer very short. 0.67. What is the ratio of the Value added (% of GDP) in Latin America(developing only) in 2006 to that in 2007?
Give a very brief answer. 1. What is the ratio of the Value added (% of GDP) of Gambia, The in 2006 to that in 2007?
Keep it short and to the point. 0.97. What is the ratio of the Value added (% of GDP) in Ghana in 2006 to that in 2007?
Your answer should be compact. 0.97. What is the ratio of the Value added (% of GDP) of Senegal in 2006 to that in 2007?
Ensure brevity in your answer.  0.98. What is the ratio of the Value added (% of GDP) of Latin America(developing only) in 2006 to that in 2008?
Provide a short and direct response. 1. What is the ratio of the Value added (% of GDP) in Gambia, The in 2006 to that in 2008?
Offer a very short reply. 1.04. What is the ratio of the Value added (% of GDP) of Senegal in 2006 to that in 2008?
Provide a short and direct response. 1. What is the ratio of the Value added (% of GDP) of Latin America(developing only) in 2006 to that in 2009?
Offer a terse response. 0.97. What is the ratio of the Value added (% of GDP) in Gambia, The in 2006 to that in 2009?
Your answer should be compact. 1.04. What is the ratio of the Value added (% of GDP) in Senegal in 2006 to that in 2009?
Your response must be concise. 1.03. What is the ratio of the Value added (% of GDP) in Gambia, The in 2007 to that in 2008?
Make the answer very short. 1.07. What is the ratio of the Value added (% of GDP) in Ghana in 2007 to that in 2008?
Give a very brief answer. 1.04. What is the ratio of the Value added (% of GDP) in Senegal in 2007 to that in 2008?
Your answer should be compact. 1.02. What is the ratio of the Value added (% of GDP) in Latin America(developing only) in 2007 to that in 2009?
Offer a terse response. 0.98. What is the ratio of the Value added (% of GDP) of Gambia, The in 2007 to that in 2009?
Give a very brief answer. 1.07. What is the ratio of the Value added (% of GDP) in Ghana in 2007 to that in 2009?
Offer a very short reply. 1.03. What is the ratio of the Value added (% of GDP) of Senegal in 2007 to that in 2009?
Provide a short and direct response. 1.04. What is the ratio of the Value added (% of GDP) of Latin America(developing only) in 2008 to that in 2009?
Your response must be concise. 0.97. What is the ratio of the Value added (% of GDP) in Senegal in 2008 to that in 2009?
Give a very brief answer. 1.03. What is the difference between the highest and the second highest Value added (% of GDP) of Latin America(developing only)?
Keep it short and to the point. 1.47. What is the difference between the highest and the second highest Value added (% of GDP) of Gambia, The?
Keep it short and to the point. 1.8. What is the difference between the highest and the second highest Value added (% of GDP) of Ghana?
Your answer should be compact. 1.43. What is the difference between the highest and the second highest Value added (% of GDP) of Senegal?
Provide a succinct answer. 0.97. What is the difference between the highest and the lowest Value added (% of GDP) of Latin America(developing only)?
Your answer should be compact. 2.16. What is the difference between the highest and the lowest Value added (% of GDP) of Gambia, The?
Make the answer very short. 6.94. What is the difference between the highest and the lowest Value added (% of GDP) of Ghana?
Your response must be concise. 17.63. What is the difference between the highest and the lowest Value added (% of GDP) of Senegal?
Your response must be concise. 2.68. 